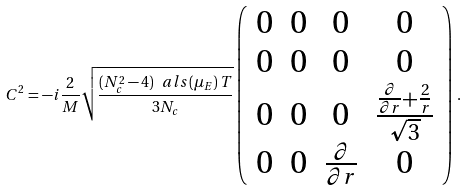<formula> <loc_0><loc_0><loc_500><loc_500>C ^ { 2 } = - i \frac { 2 } { M } \sqrt { \frac { ( N _ { c } ^ { 2 } - 4 ) \ a l s ( \mu _ { E } ) \, T } { 3 N _ { c } } } \left ( \begin{array} { c c c c } 0 & 0 & 0 & 0 \\ 0 & 0 & 0 & 0 \\ 0 & 0 & 0 & \frac { \frac { \partial } { \partial r } + \frac { 2 } { r } } { \sqrt { 3 } } \\ 0 & 0 & \frac { \partial } { \partial r } & 0 \end{array} \right ) \, .</formula> 